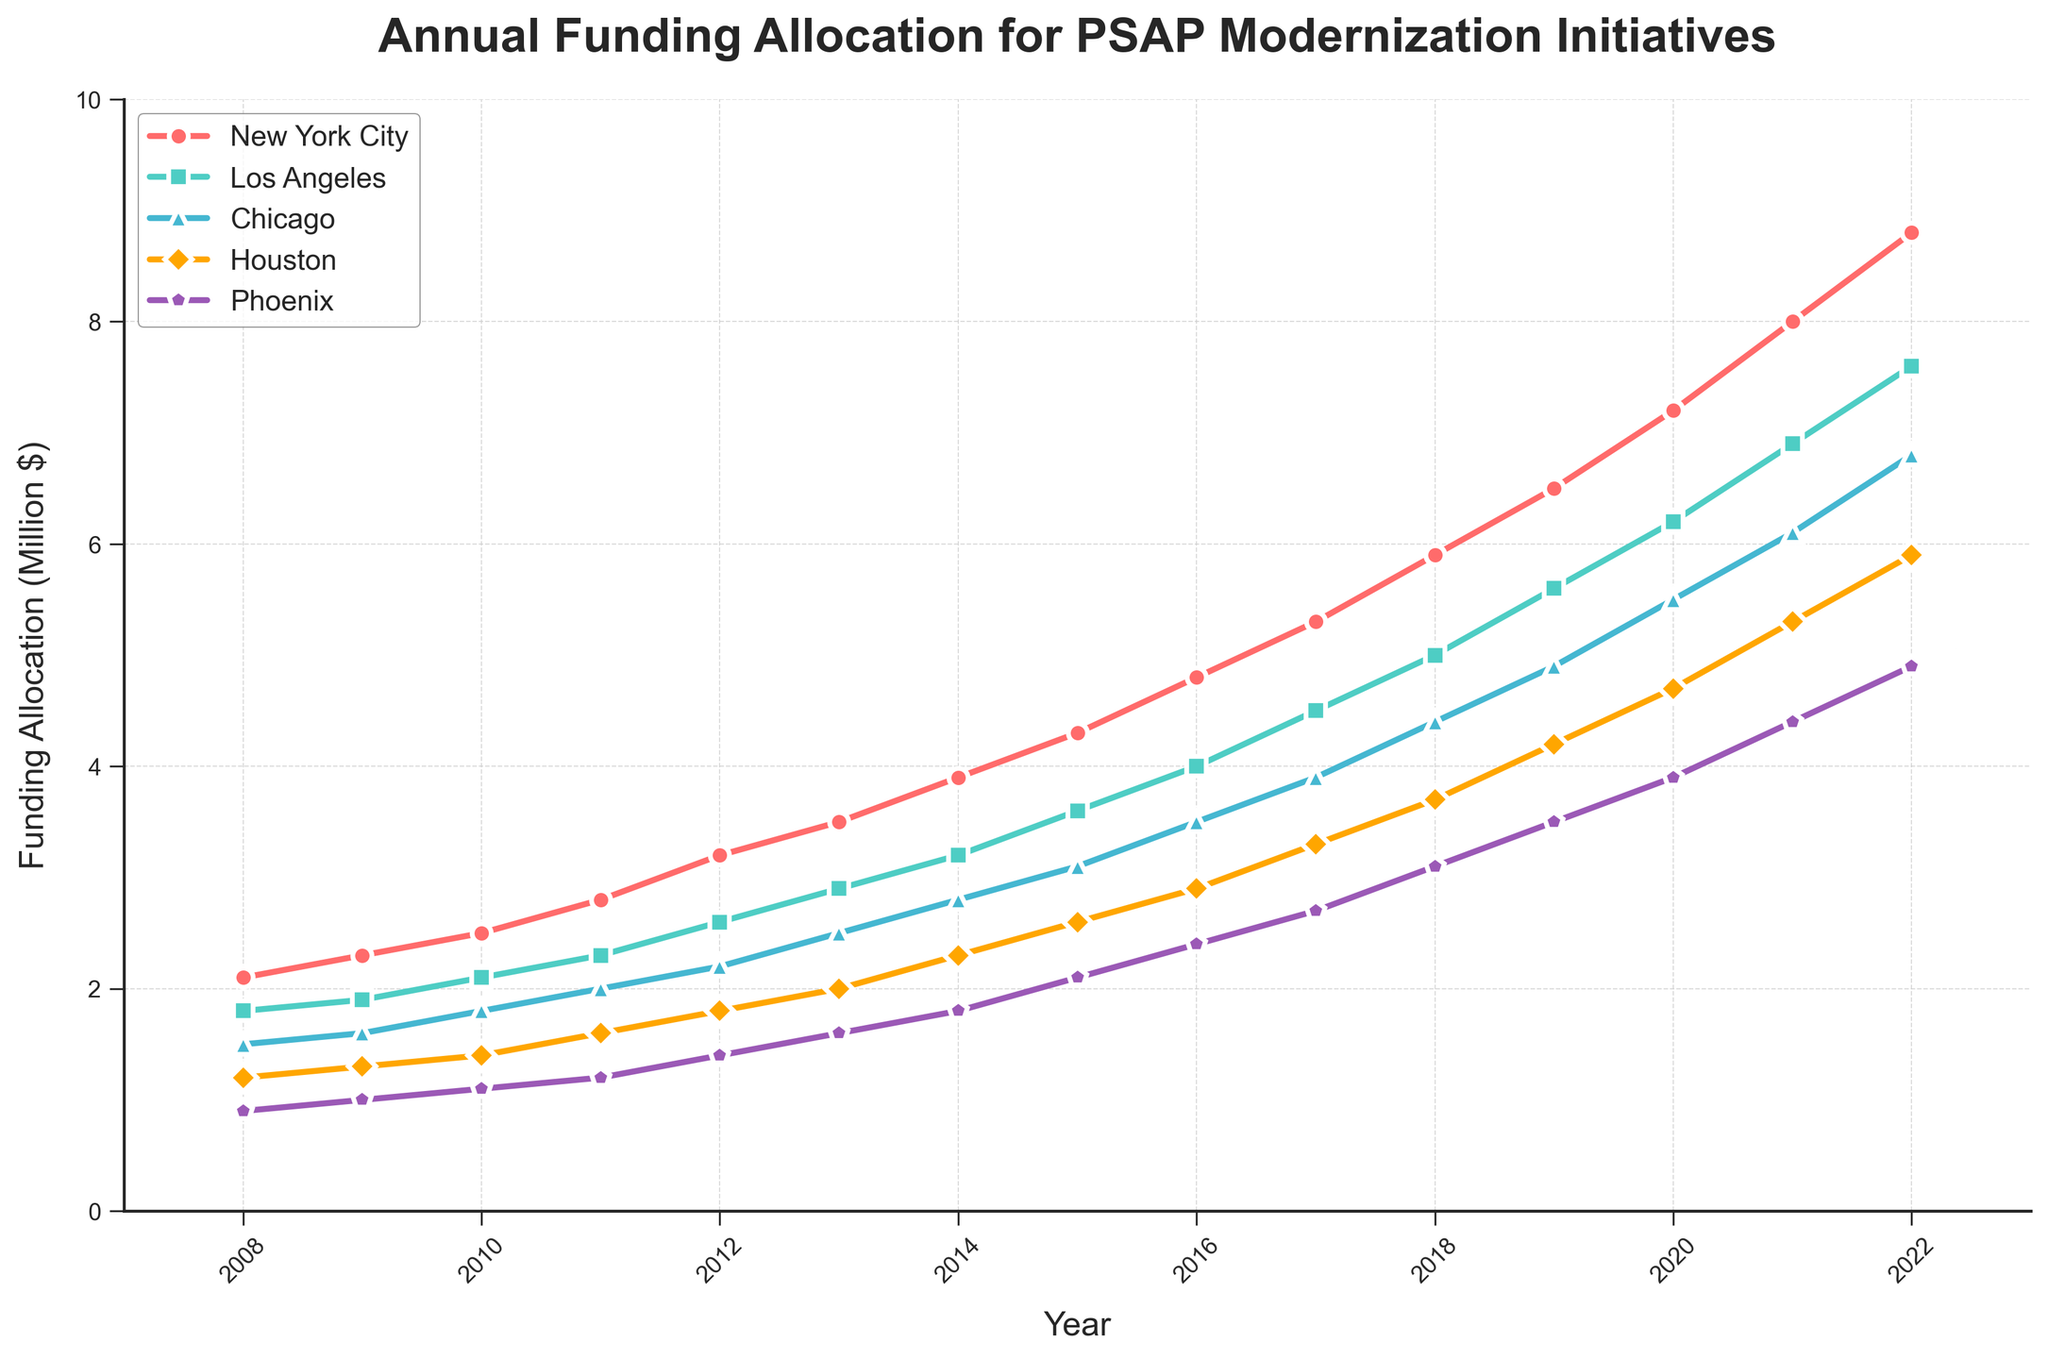What is the total funding allocation for Houston in the year 2022? To find Houston's total funding allocation in 2022, look at the line corresponding to Houston and read the y-axis value for the year 2022.
Answer: 5.9 million Which city had the highest rate of increase in funding allocation from 2008 to 2022? By observing the slopes of the lines, notice which one has the steepest gradient from 2008 to 2022. The steepest line represents the highest rate.
Answer: New York City By how much did the funding allocation for Phoenix increase from 2008 to 2022? Find the funding for Phoenix in 2008 and 2022 from the plot, then calculate the difference: 4.9 (2022) - 0.9 (2008).
Answer: 4 million What is the average funding allocation for Chicago from 2015 to 2020? Add Chicago's funding values for 2015, 2016, 2017, 2018, 2019, and 2020, then divide by the number of years: (3.1 + 3.5 + 3.9 + 4.4 + 4.9 + 5.5) / 6.
Answer: 4.22 million Comparing funding allocations in 2012, which city had the smallest amount and by how much does it differ from the city with the highest amount? Identify the 2012 values for all cities and find the minimum (Phoenix) and maximum (New York City). Calculate the difference: 3.2 - 1.4.
Answer: Phoenix, 1.8 million Which city surpassed the 4 million mark in funding allocation first and in which year? Observe the lines and identify which one crosses the 4 million threshold first.
Answer: New York City, in 2015 What’s the average annual increase in funding allocation for Los Angeles from 2008 to 2022? Find the difference in funding from 2022 and 2008, then divide by the number of years: (7.6 - 1.8) / (2022 - 2008).
Answer: 0.414 million Who had the smallest increase in funding allocation between 2017 and 2022? Calculate the increase for each city during this period and compare: NYC (8.8-5.3), LA (7.6-4.5), Chicago (6.8-3.9), Houston (5.9-3.3), Phoenix (4.9-2.7).
Answer: Chicago Between 2010 and 2015, which city had the most consistent, gradual increase in funding allocation? Check the steadiness and regularity of the line slopes for each city between 2010 and 2015.
Answer: Los Angeles 